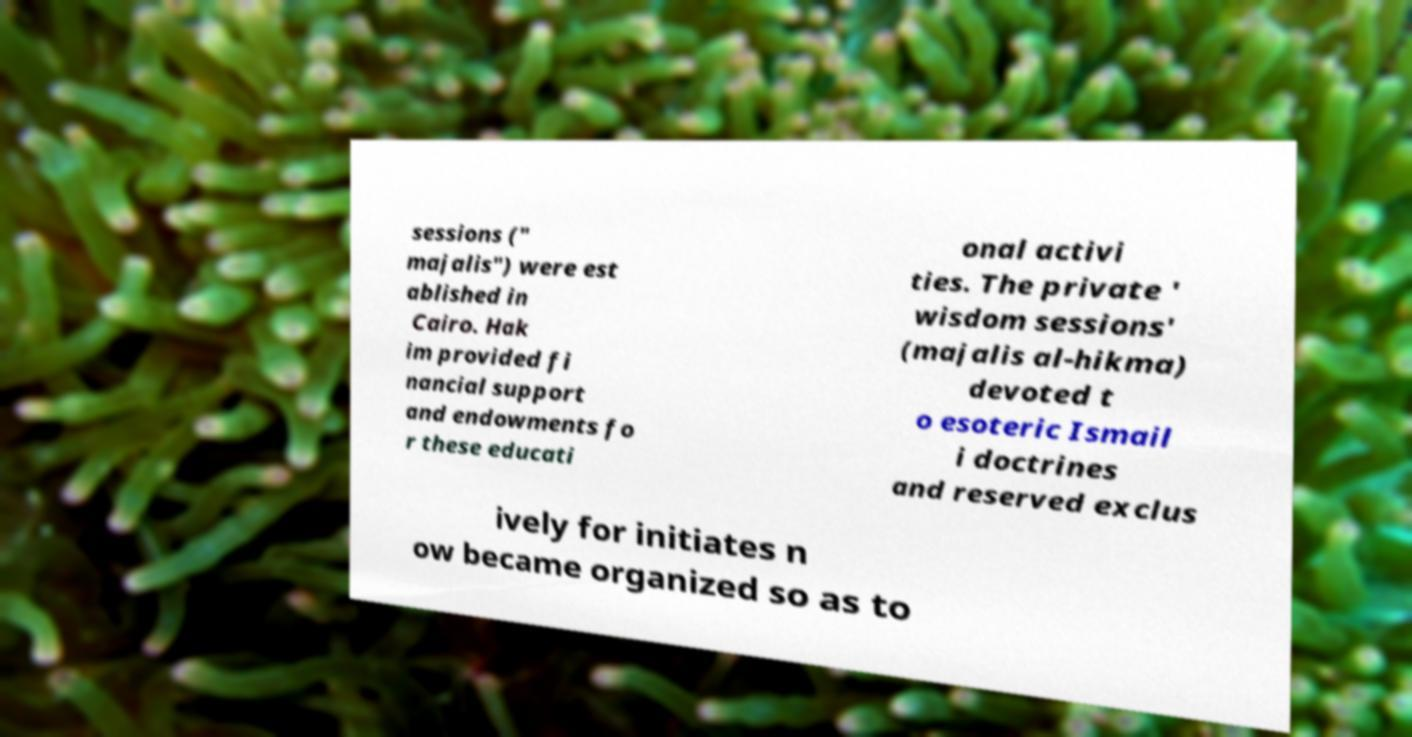Please read and relay the text visible in this image. What does it say? sessions (" majalis") were est ablished in Cairo. Hak im provided fi nancial support and endowments fo r these educati onal activi ties. The private ' wisdom sessions' (majalis al-hikma) devoted t o esoteric Ismail i doctrines and reserved exclus ively for initiates n ow became organized so as to 